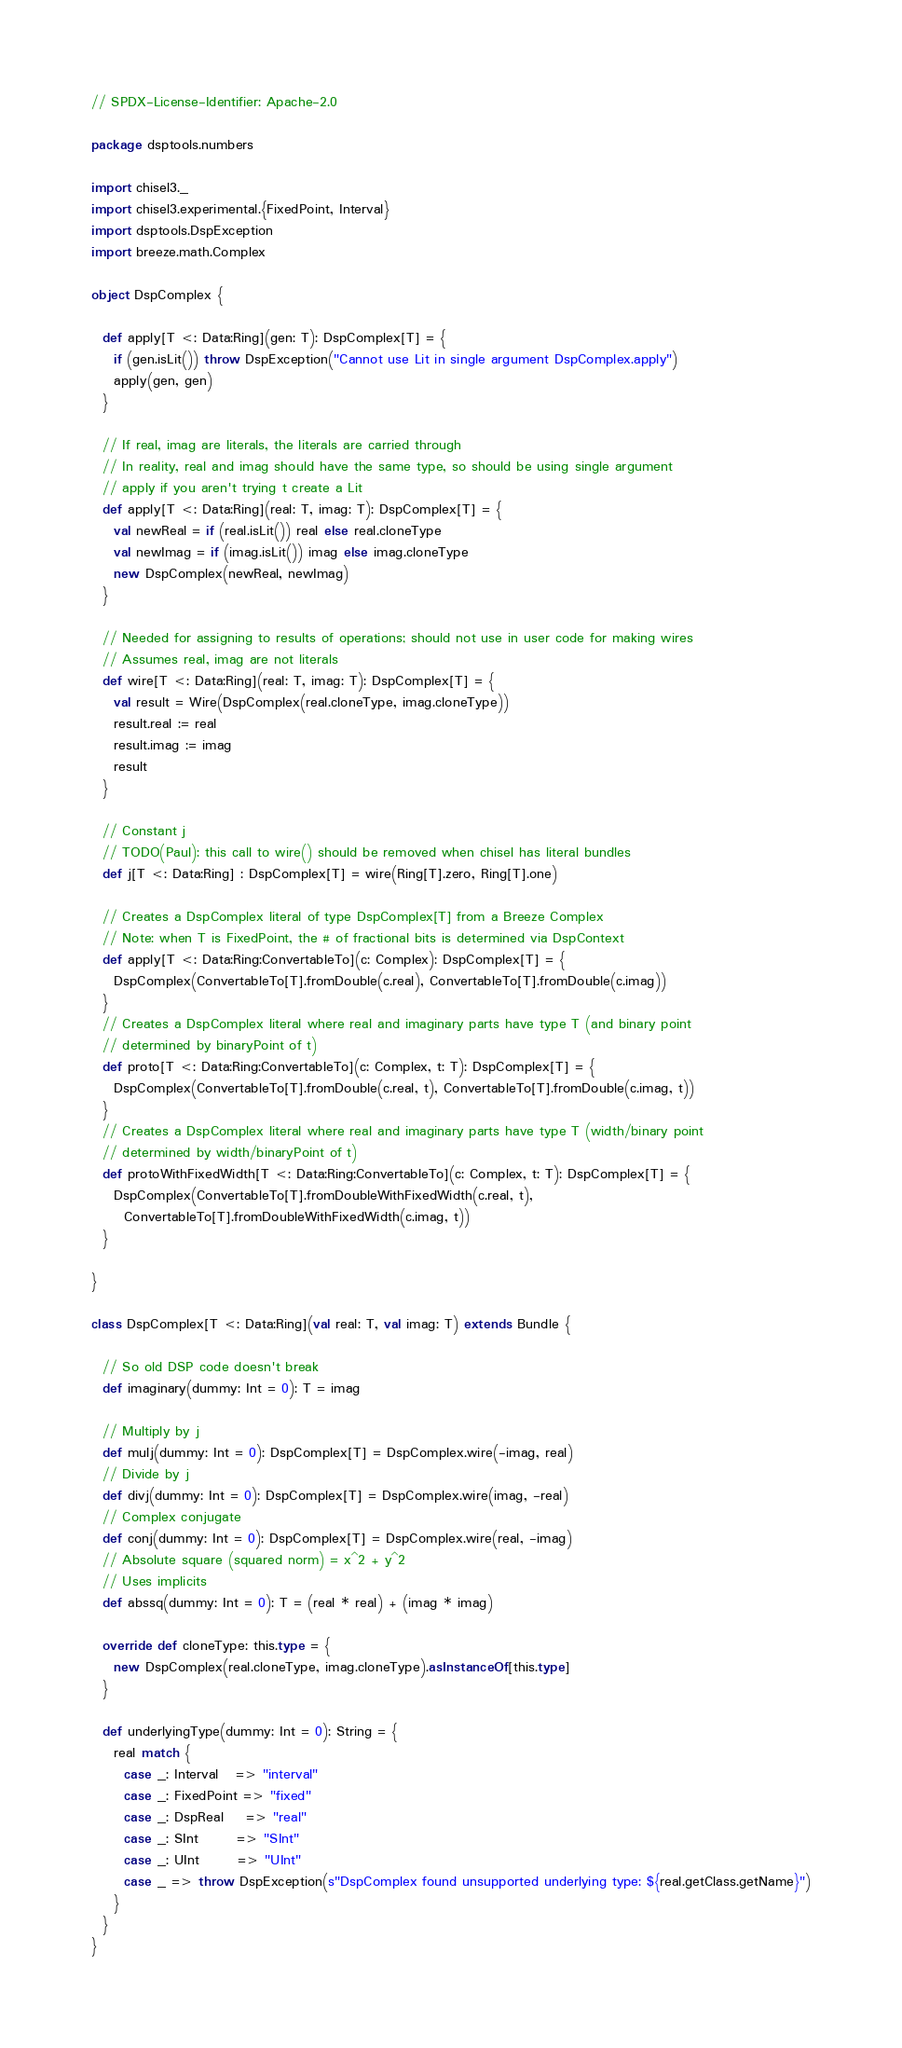<code> <loc_0><loc_0><loc_500><loc_500><_Scala_>// SPDX-License-Identifier: Apache-2.0

package dsptools.numbers

import chisel3._
import chisel3.experimental.{FixedPoint, Interval}
import dsptools.DspException
import breeze.math.Complex

object DspComplex {

  def apply[T <: Data:Ring](gen: T): DspComplex[T] = {
    if (gen.isLit()) throw DspException("Cannot use Lit in single argument DspComplex.apply")
    apply(gen, gen)
  }

  // If real, imag are literals, the literals are carried through
  // In reality, real and imag should have the same type, so should be using single argument
  // apply if you aren't trying t create a Lit
  def apply[T <: Data:Ring](real: T, imag: T): DspComplex[T] = {
    val newReal = if (real.isLit()) real else real.cloneType
    val newImag = if (imag.isLit()) imag else imag.cloneType
    new DspComplex(newReal, newImag)
  }

  // Needed for assigning to results of operations; should not use in user code for making wires
  // Assumes real, imag are not literals
  def wire[T <: Data:Ring](real: T, imag: T): DspComplex[T] = {
    val result = Wire(DspComplex(real.cloneType, imag.cloneType))
    result.real := real
    result.imag := imag
    result
  }

  // Constant j
  // TODO(Paul): this call to wire() should be removed when chisel has literal bundles
  def j[T <: Data:Ring] : DspComplex[T] = wire(Ring[T].zero, Ring[T].one)

  // Creates a DspComplex literal of type DspComplex[T] from a Breeze Complex
  // Note: when T is FixedPoint, the # of fractional bits is determined via DspContext
  def apply[T <: Data:Ring:ConvertableTo](c: Complex): DspComplex[T] = {
    DspComplex(ConvertableTo[T].fromDouble(c.real), ConvertableTo[T].fromDouble(c.imag))
  }
  // Creates a DspComplex literal where real and imaginary parts have type T (and binary point 
  // determined by binaryPoint of t)
  def proto[T <: Data:Ring:ConvertableTo](c: Complex, t: T): DspComplex[T] = {
    DspComplex(ConvertableTo[T].fromDouble(c.real, t), ConvertableTo[T].fromDouble(c.imag, t))
  }
  // Creates a DspComplex literal where real and imaginary parts have type T (width/binary point 
  // determined by width/binaryPoint of t)
  def protoWithFixedWidth[T <: Data:Ring:ConvertableTo](c: Complex, t: T): DspComplex[T] = {
    DspComplex(ConvertableTo[T].fromDoubleWithFixedWidth(c.real, t), 
      ConvertableTo[T].fromDoubleWithFixedWidth(c.imag, t))
  }

}

class DspComplex[T <: Data:Ring](val real: T, val imag: T) extends Bundle {
  
  // So old DSP code doesn't break
  def imaginary(dummy: Int = 0): T = imag

  // Multiply by j
  def mulj(dummy: Int = 0): DspComplex[T] = DspComplex.wire(-imag, real)
  // Divide by j
  def divj(dummy: Int = 0): DspComplex[T] = DspComplex.wire(imag, -real)
  // Complex conjugate
  def conj(dummy: Int = 0): DspComplex[T] = DspComplex.wire(real, -imag)
  // Absolute square (squared norm) = x^2 + y^2
  // Uses implicits
  def abssq(dummy: Int = 0): T = (real * real) + (imag * imag)

  override def cloneType: this.type = {
    new DspComplex(real.cloneType, imag.cloneType).asInstanceOf[this.type]
  }

  def underlyingType(dummy: Int = 0): String = {
    real match {
      case _: Interval   => "interval"
      case _: FixedPoint => "fixed"
      case _: DspReal    => "real"
      case _: SInt       => "SInt"
      case _: UInt       => "UInt"
      case _ => throw DspException(s"DspComplex found unsupported underlying type: ${real.getClass.getName}")
    }
  }
}
</code> 